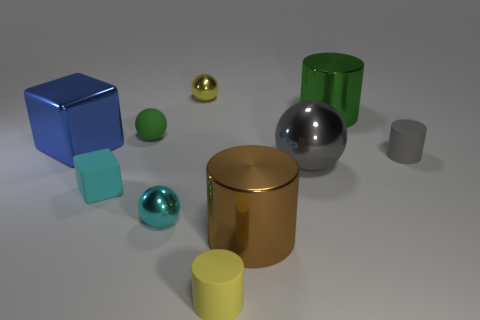What material is the small yellow thing that is the same shape as the small gray thing?
Your answer should be compact. Rubber. What number of other things are there of the same color as the large metal cube?
Offer a very short reply. 0. Are there more large spheres than cylinders?
Offer a terse response. No. There is a yellow rubber cylinder; is its size the same as the metallic ball behind the small gray thing?
Provide a short and direct response. Yes. There is a metal sphere behind the blue object; what is its color?
Provide a succinct answer. Yellow. How many gray things are either tiny rubber cylinders or big shiny cubes?
Provide a succinct answer. 1. The tiny cube has what color?
Provide a short and direct response. Cyan. Is there any other thing that has the same material as the small gray thing?
Provide a succinct answer. Yes. Is the number of blue shiny blocks left of the big blue block less than the number of large spheres that are to the right of the green shiny object?
Make the answer very short. No. The matte thing that is behind the big gray metallic sphere and to the left of the large brown shiny object has what shape?
Offer a very short reply. Sphere. 